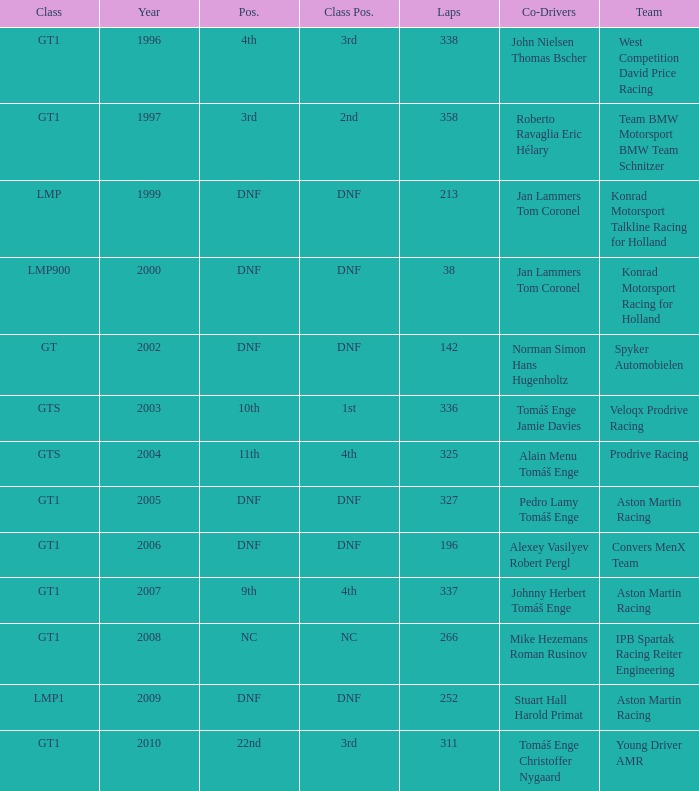Which team finished 3rd in class with 337 laps before 2008? West Competition David Price Racing. 